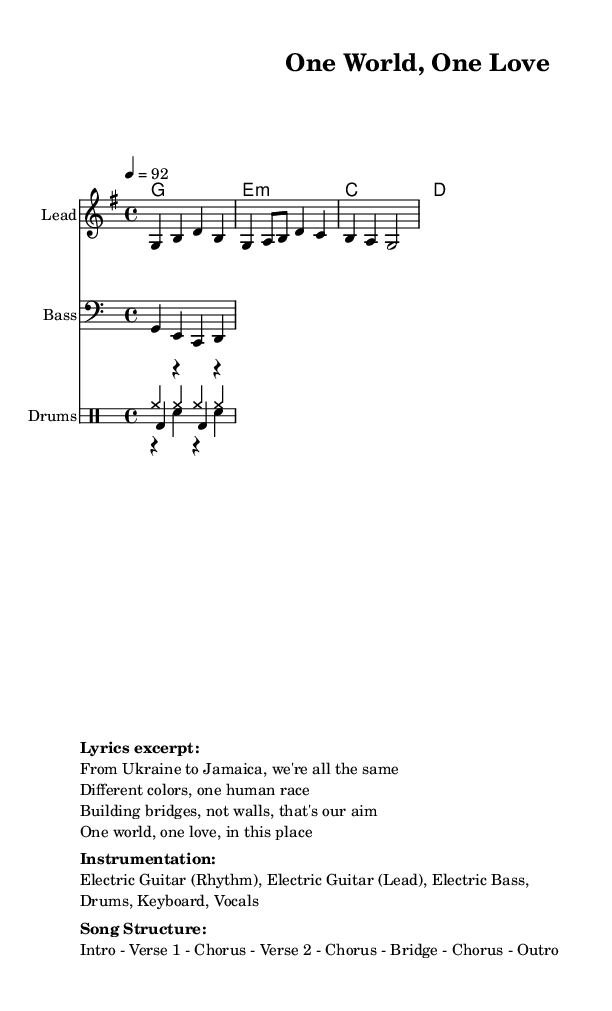What is the key signature of this music? The key signature of the piece is G major, which has one sharp, F#. This can be determined by looking at the global settings in the sheet music.
Answer: G major What is the time signature of this music? The time signature in the music sheet is 4/4, as indicated in the global settings. This means there are four beats in each measure, and a quarter note gets one beat.
Answer: 4/4 What is the tempo marking for this piece? The tempo marking is 92 beats per minute (bpm). This is specified in the global section of the sheet music, indicating the speed at which the piece should be played.
Answer: 92 How many instruments are listed in the instrumentation? The instrumentation lists five different instruments: Electric Guitar (Rhythm), Electric Guitar (Lead), Electric Bass, Drums, Keyboard, and Vocals. This can be counted from the markup section.
Answer: Six What is the song structure presented in the music? The song structure is defined as: Intro - Verse 1 - Chorus - Verse 2 - Chorus - Bridge - Chorus - Outro. This is detailed within the markup section, showing the arrangement of the song.
Answer: Intro - Verse 1 - Chorus - Verse 2 - Chorus - Bridge - Chorus - Outro What is the overarching message of the lyrics excerpt? The overarching message is one of unity and cultural diversity, as indicated by lines like "From Ukraine to Jamaica, we're all the same" and "One world, one love, in this place." These lines emphasize the idea of togetherness across cultures.
Answer: Unity and diversity How does the chord progression support the theme of the song? The chord progression (G, e minor, C, D) supports the theme of unity and positivity commonly found in reggae music. These chords create a bright and uplifting harmonic environment, encouraging a sense of togetherness.
Answer: Bright and uplifting 